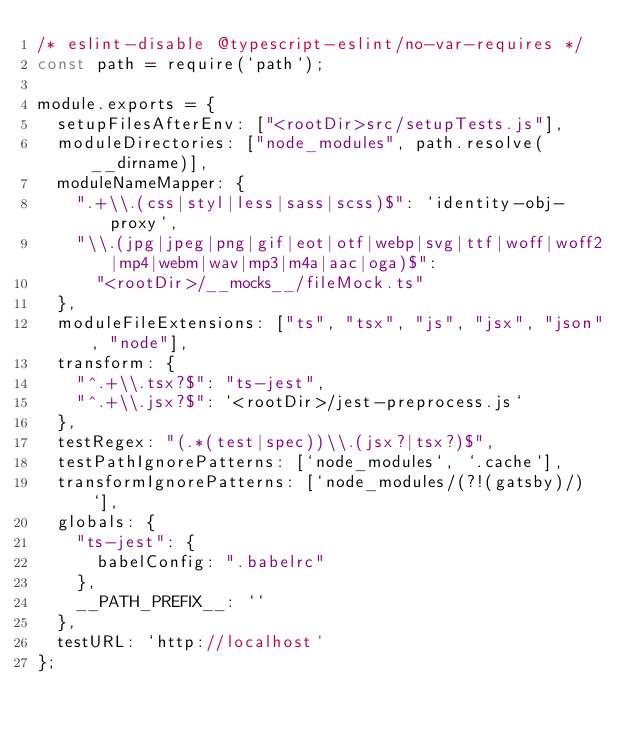Convert code to text. <code><loc_0><loc_0><loc_500><loc_500><_JavaScript_>/* eslint-disable @typescript-eslint/no-var-requires */
const path = require(`path`);

module.exports = {
  setupFilesAfterEnv: ["<rootDir>src/setupTests.js"],
  moduleDirectories: ["node_modules", path.resolve(__dirname)],
  moduleNameMapper: {
    ".+\\.(css|styl|less|sass|scss)$": `identity-obj-proxy`,
    "\\.(jpg|jpeg|png|gif|eot|otf|webp|svg|ttf|woff|woff2|mp4|webm|wav|mp3|m4a|aac|oga)$":
      "<rootDir>/__mocks__/fileMock.ts"
  },
  moduleFileExtensions: ["ts", "tsx", "js", "jsx", "json", "node"],
  transform: {
    "^.+\\.tsx?$": "ts-jest",
    "^.+\\.jsx?$": `<rootDir>/jest-preprocess.js`
  },
  testRegex: "(.*(test|spec))\\.(jsx?|tsx?)$",
  testPathIgnorePatterns: [`node_modules`, `.cache`],
  transformIgnorePatterns: [`node_modules/(?!(gatsby)/)`],
  globals: {
    "ts-jest": {
      babelConfig: ".babelrc"
    },
    __PATH_PREFIX__: ``
  },
  testURL: `http://localhost`
};
</code> 